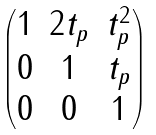Convert formula to latex. <formula><loc_0><loc_0><loc_500><loc_500>\begin{pmatrix} 1 & 2 t _ { p } & t _ { p } ^ { 2 } \\ 0 & 1 & t _ { p } \\ 0 & 0 & 1 \end{pmatrix}</formula> 